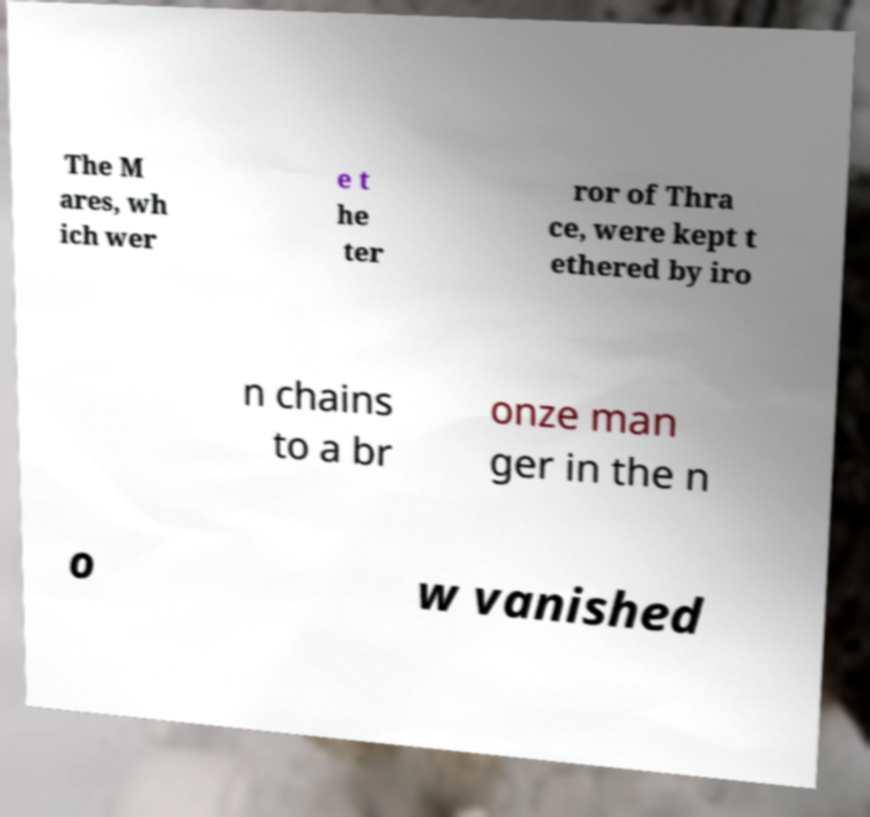There's text embedded in this image that I need extracted. Can you transcribe it verbatim? The M ares, wh ich wer e t he ter ror of Thra ce, were kept t ethered by iro n chains to a br onze man ger in the n o w vanished 